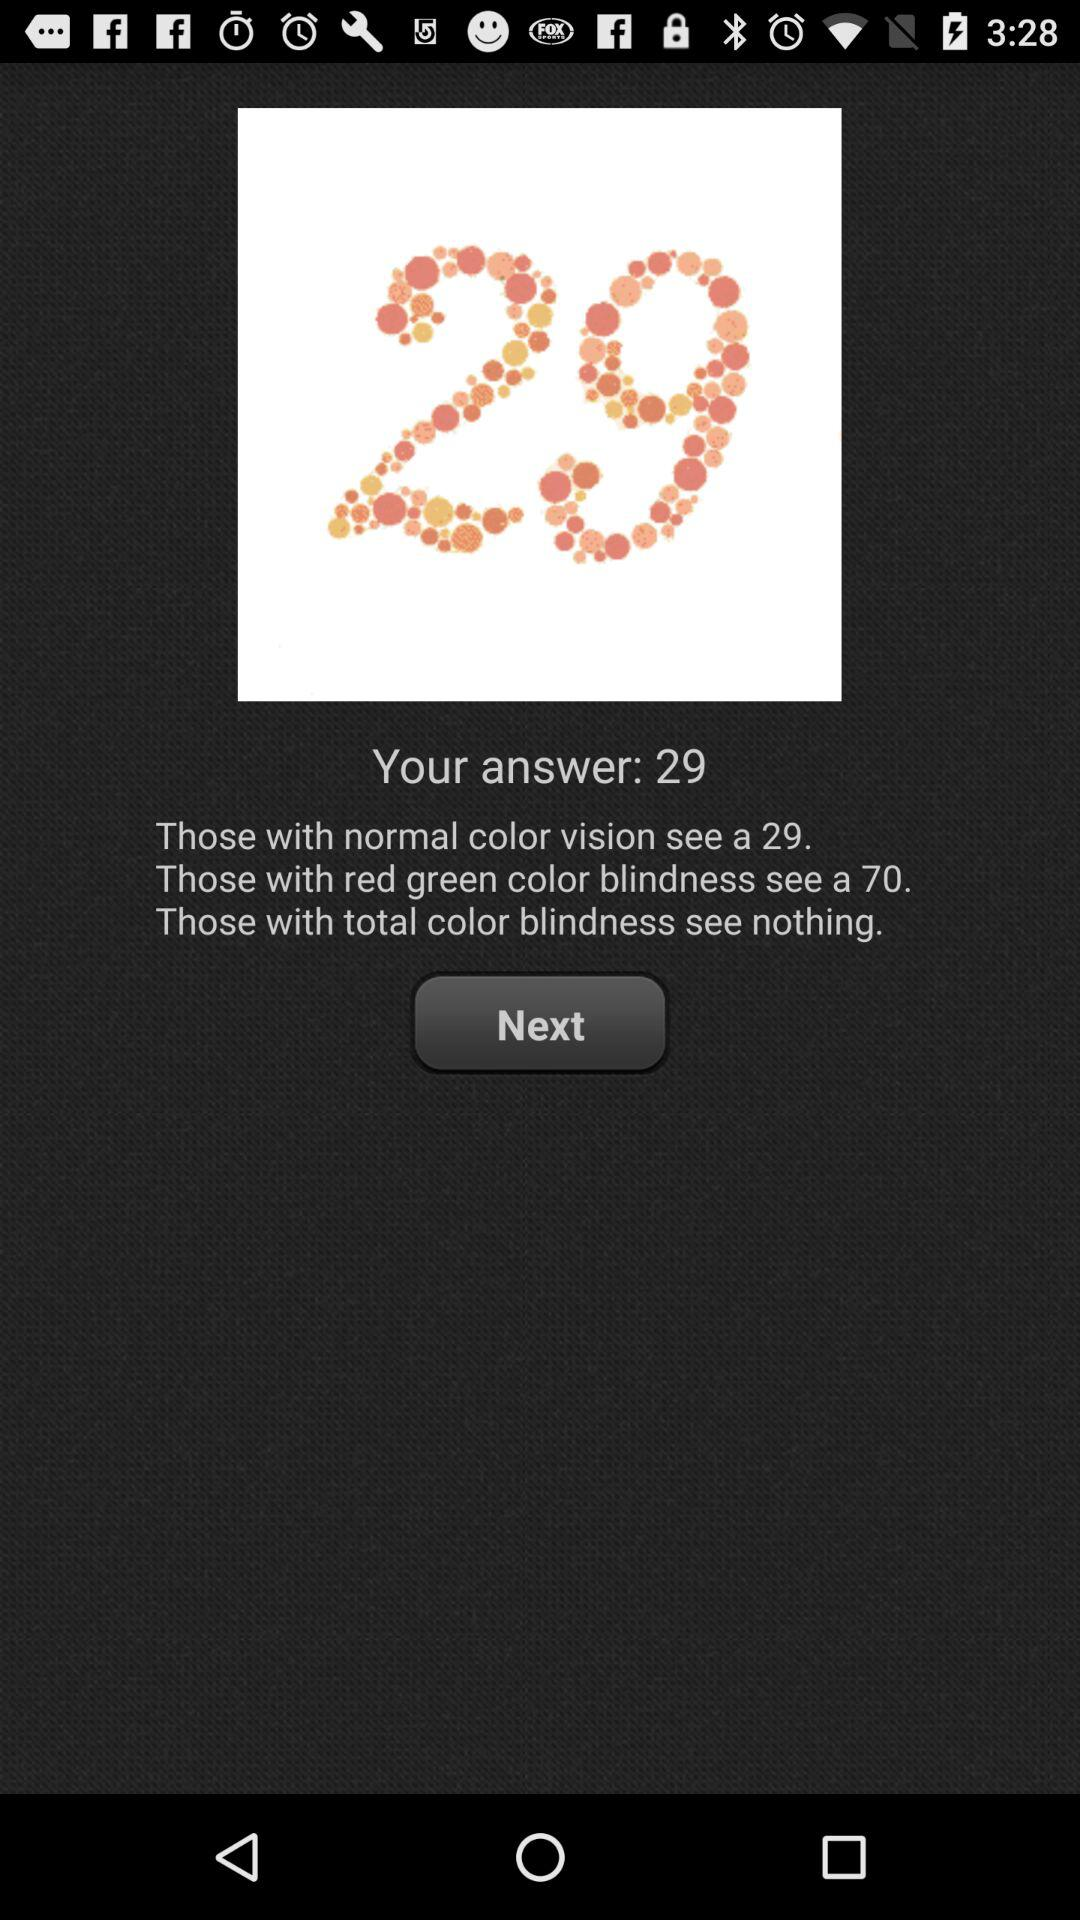Who can see a 70? Those with red green color blindness can see a 70. 